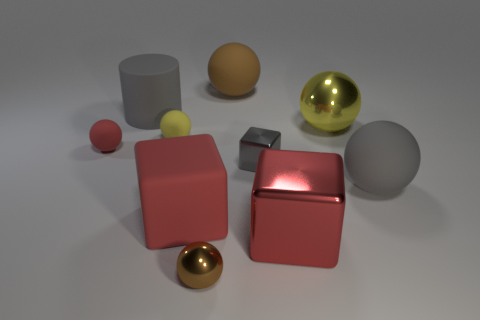Subtract 3 balls. How many balls are left? 3 Subtract all large brown rubber balls. How many balls are left? 5 Subtract all yellow spheres. How many spheres are left? 4 Subtract all gray balls. Subtract all red cubes. How many balls are left? 5 Subtract all cubes. How many objects are left? 7 Add 3 large matte cubes. How many large matte cubes are left? 4 Add 1 tiny rubber balls. How many tiny rubber balls exist? 3 Subtract 0 blue cubes. How many objects are left? 10 Subtract all small gray matte spheres. Subtract all brown rubber objects. How many objects are left? 9 